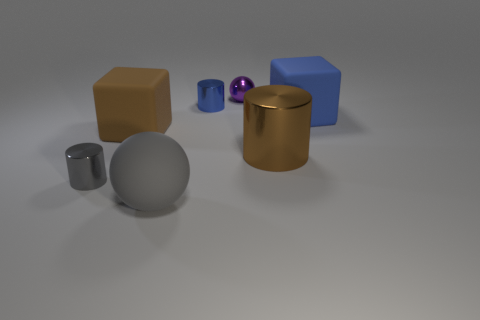There is a cylinder that is left of the matte sphere; does it have the same size as the blue shiny object?
Offer a very short reply. Yes. How many other objects are the same size as the brown cylinder?
Provide a succinct answer. 3. The small sphere has what color?
Your answer should be compact. Purple. There is a purple object that is behind the tiny gray metallic thing; what material is it?
Make the answer very short. Metal. Are there the same number of tiny blue metallic cylinders left of the metal ball and brown things?
Make the answer very short. No. Is the big gray rubber thing the same shape as the tiny purple metallic thing?
Your response must be concise. Yes. Are there any other things of the same color as the small shiny sphere?
Your answer should be very brief. No. What shape is the metallic object that is on the left side of the purple thing and in front of the small blue cylinder?
Your answer should be very brief. Cylinder. Are there an equal number of big things that are left of the blue cylinder and small metal objects on the right side of the small gray cylinder?
Your answer should be very brief. Yes. How many spheres are matte objects or tiny blue metal objects?
Make the answer very short. 1. 